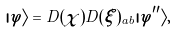Convert formula to latex. <formula><loc_0><loc_0><loc_500><loc_500>| \varphi \rangle = D ( \chi ) D ( \xi ) _ { a b } | \varphi ^ { \prime \prime } \rangle ,</formula> 